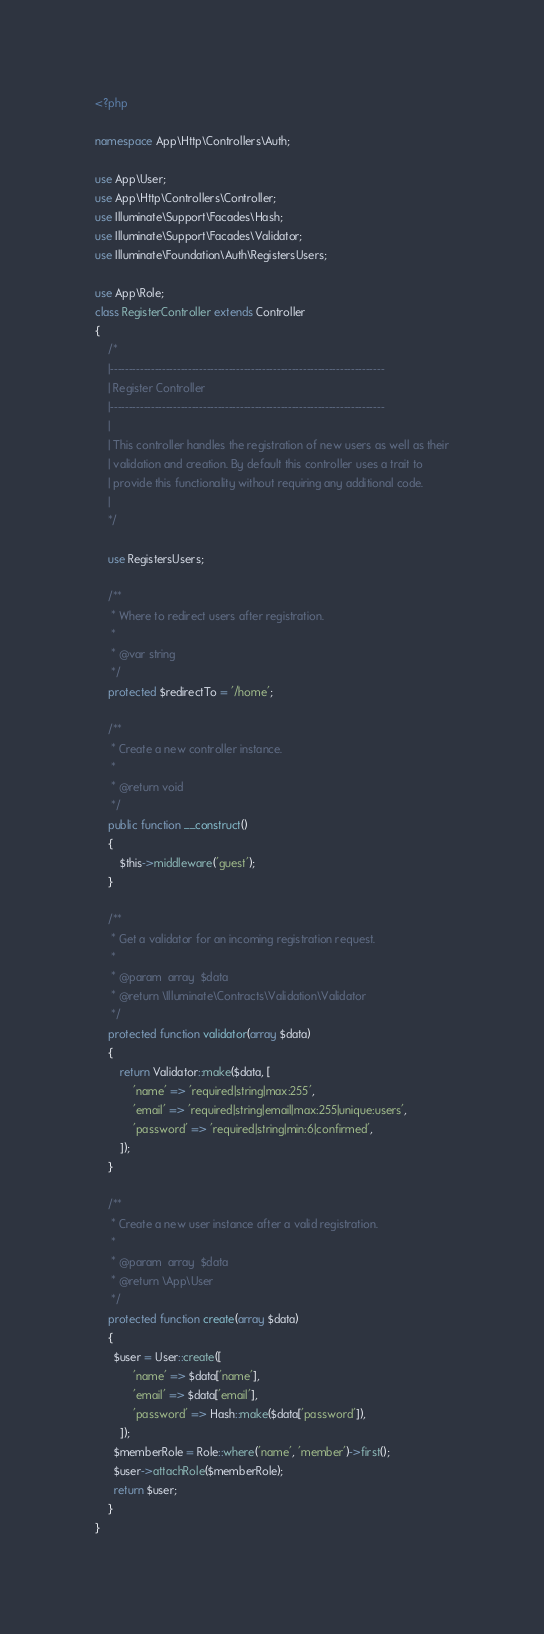Convert code to text. <code><loc_0><loc_0><loc_500><loc_500><_PHP_><?php

namespace App\Http\Controllers\Auth;

use App\User;
use App\Http\Controllers\Controller;
use Illuminate\Support\Facades\Hash;
use Illuminate\Support\Facades\Validator;
use Illuminate\Foundation\Auth\RegistersUsers;

use App\Role;
class RegisterController extends Controller
{
    /*
    |--------------------------------------------------------------------------
    | Register Controller
    |--------------------------------------------------------------------------
    |
    | This controller handles the registration of new users as well as their
    | validation and creation. By default this controller uses a trait to
    | provide this functionality without requiring any additional code.
    |
    */

    use RegistersUsers;

    /**
     * Where to redirect users after registration.
     *
     * @var string
     */
    protected $redirectTo = '/home';

    /**
     * Create a new controller instance.
     *
     * @return void
     */
    public function __construct()
    {
        $this->middleware('guest');
    }

    /**
     * Get a validator for an incoming registration request.
     *
     * @param  array  $data
     * @return \Illuminate\Contracts\Validation\Validator
     */
    protected function validator(array $data)
    {
        return Validator::make($data, [
            'name' => 'required|string|max:255',
            'email' => 'required|string|email|max:255|unique:users',
            'password' => 'required|string|min:6|confirmed',
        ]);
    }

    /**
     * Create a new user instance after a valid registration.
     *
     * @param  array  $data
     * @return \App\User
     */
    protected function create(array $data)
    {
      $user = User::create([
            'name' => $data['name'],
            'email' => $data['email'],
            'password' => Hash::make($data['password']),
        ]);
      $memberRole = Role::where('name', 'member')->first();
      $user->attachRole($memberRole);
      return $user;
    }
}
</code> 